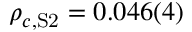<formula> <loc_0><loc_0><loc_500><loc_500>\rho _ { c , S 2 } = 0 . 0 4 6 ( 4 )</formula> 